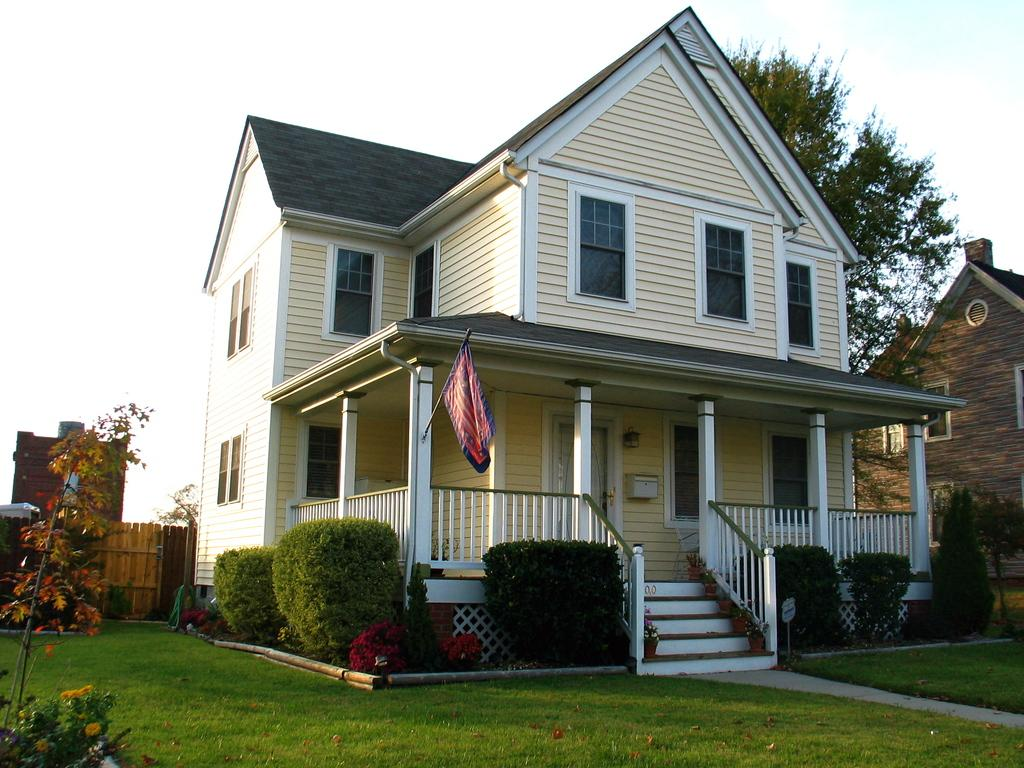How many buildings are in the image? There are two buildings in the image. What colors are the buildings? One building is cream-colored, and the other is brown-colored. What type of vegetation is present in the image? There are trees and grass in the image. What color are the trees and grass? The trees are green, and the grass is green. What part of the natural environment is visible in the image? The sky is visible in the image. What type of spacecraft can be seen in the image? There is no spacecraft present in the image; it features two buildings, trees, grass, and a sky. What type of crate is visible in the image? There is no crate present in the image. 